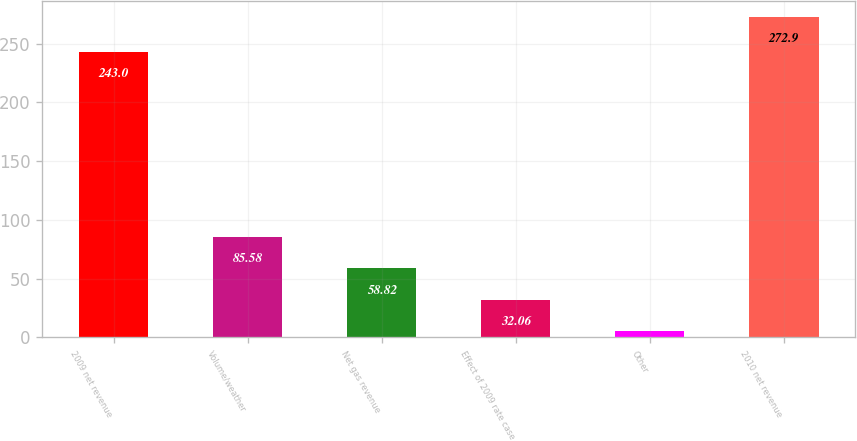Convert chart. <chart><loc_0><loc_0><loc_500><loc_500><bar_chart><fcel>2009 net revenue<fcel>Volume/weather<fcel>Net gas revenue<fcel>Effect of 2009 rate case<fcel>Other<fcel>2010 net revenue<nl><fcel>243<fcel>85.58<fcel>58.82<fcel>32.06<fcel>5.3<fcel>272.9<nl></chart> 